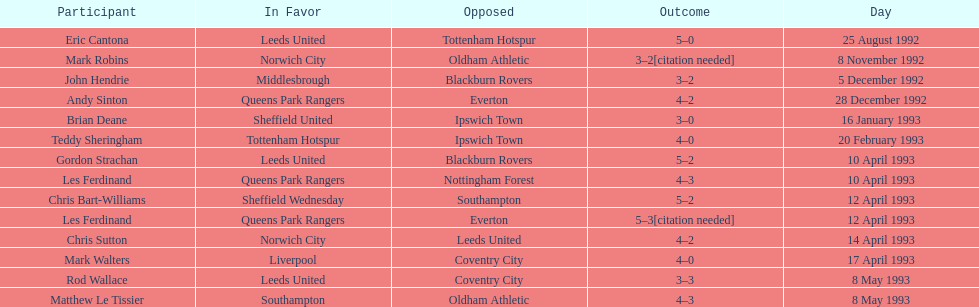Who does john hendrie play for? Middlesbrough. 